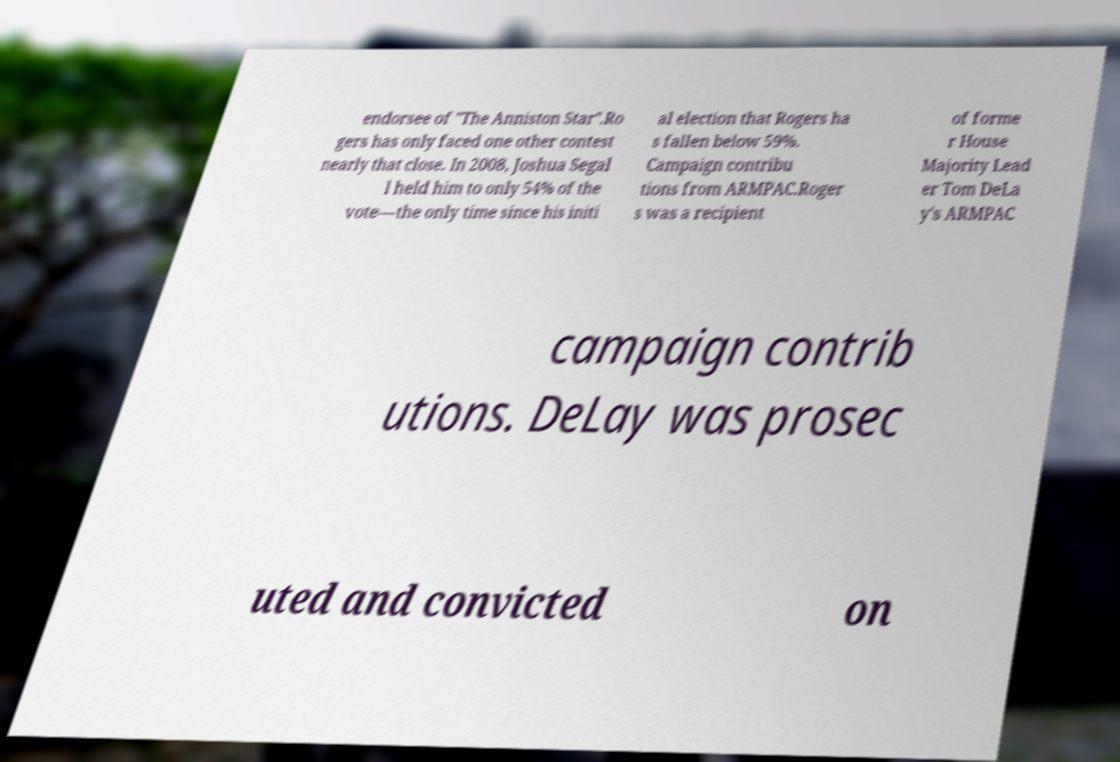Can you read and provide the text displayed in the image?This photo seems to have some interesting text. Can you extract and type it out for me? endorsee of "The Anniston Star".Ro gers has only faced one other contest nearly that close. In 2008, Joshua Segal l held him to only 54% of the vote—the only time since his initi al election that Rogers ha s fallen below 59%. Campaign contribu tions from ARMPAC.Roger s was a recipient of forme r House Majority Lead er Tom DeLa y's ARMPAC campaign contrib utions. DeLay was prosec uted and convicted on 